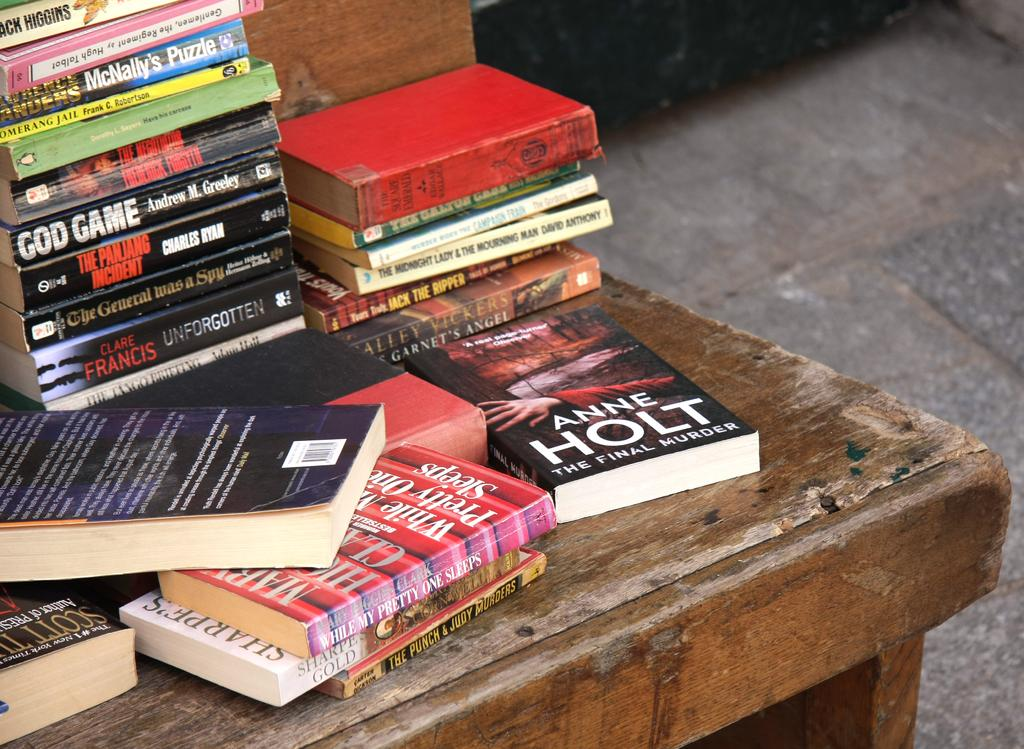Provide a one-sentence caption for the provided image. A book by Anne Holt is on a table with other books. 